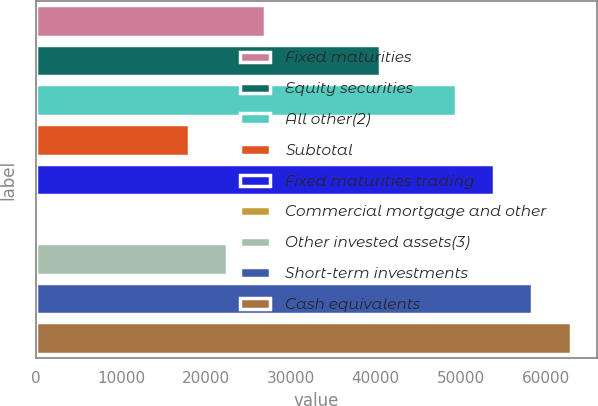Convert chart. <chart><loc_0><loc_0><loc_500><loc_500><bar_chart><fcel>Fixed maturities<fcel>Equity securities<fcel>All other(2)<fcel>Subtotal<fcel>Fixed maturities trading<fcel>Commercial mortgage and other<fcel>Other invested assets(3)<fcel>Short-term investments<fcel>Cash equivalents<nl><fcel>26973.9<fcel>40460.5<fcel>49451.5<fcel>17982.8<fcel>53947.1<fcel>0.75<fcel>22478.4<fcel>58442.6<fcel>62938.1<nl></chart> 